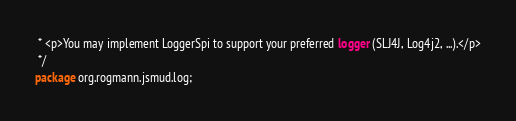<code> <loc_0><loc_0><loc_500><loc_500><_Java_> * <p>You may implement LoggerSpi to support your preferred logger (SLJ4J, Log4j2, ...).</p>
 */
package org.rogmann.jsmud.log;</code> 